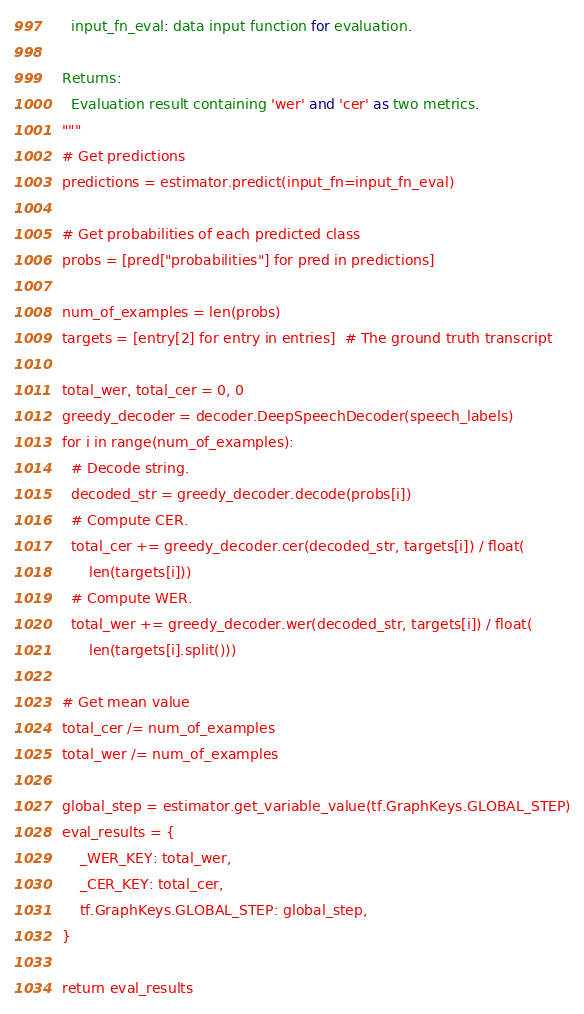Convert code to text. <code><loc_0><loc_0><loc_500><loc_500><_Python_>    input_fn_eval: data input function for evaluation.

  Returns:
    Evaluation result containing 'wer' and 'cer' as two metrics.
  """
  # Get predictions
  predictions = estimator.predict(input_fn=input_fn_eval)

  # Get probabilities of each predicted class
  probs = [pred["probabilities"] for pred in predictions]

  num_of_examples = len(probs)
  targets = [entry[2] for entry in entries]  # The ground truth transcript

  total_wer, total_cer = 0, 0
  greedy_decoder = decoder.DeepSpeechDecoder(speech_labels)
  for i in range(num_of_examples):
    # Decode string.
    decoded_str = greedy_decoder.decode(probs[i])
    # Compute CER.
    total_cer += greedy_decoder.cer(decoded_str, targets[i]) / float(
        len(targets[i]))
    # Compute WER.
    total_wer += greedy_decoder.wer(decoded_str, targets[i]) / float(
        len(targets[i].split()))

  # Get mean value
  total_cer /= num_of_examples
  total_wer /= num_of_examples

  global_step = estimator.get_variable_value(tf.GraphKeys.GLOBAL_STEP)
  eval_results = {
      _WER_KEY: total_wer,
      _CER_KEY: total_cer,
      tf.GraphKeys.GLOBAL_STEP: global_step,
  }

  return eval_results

</code> 